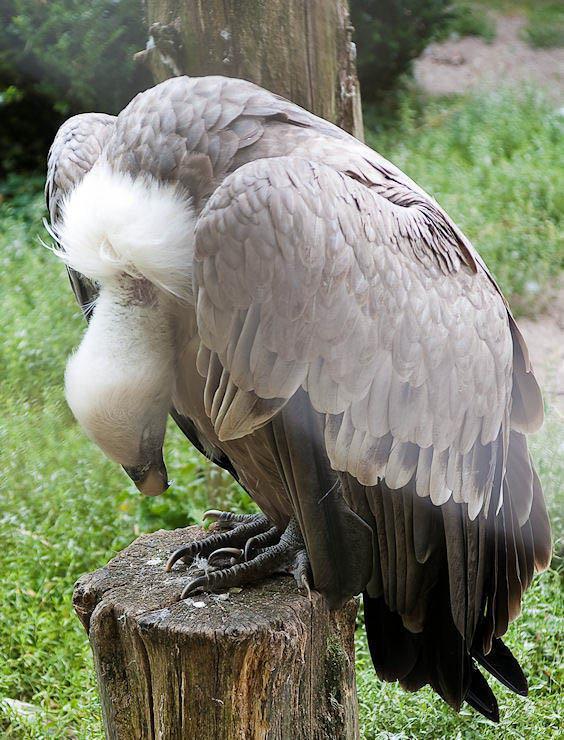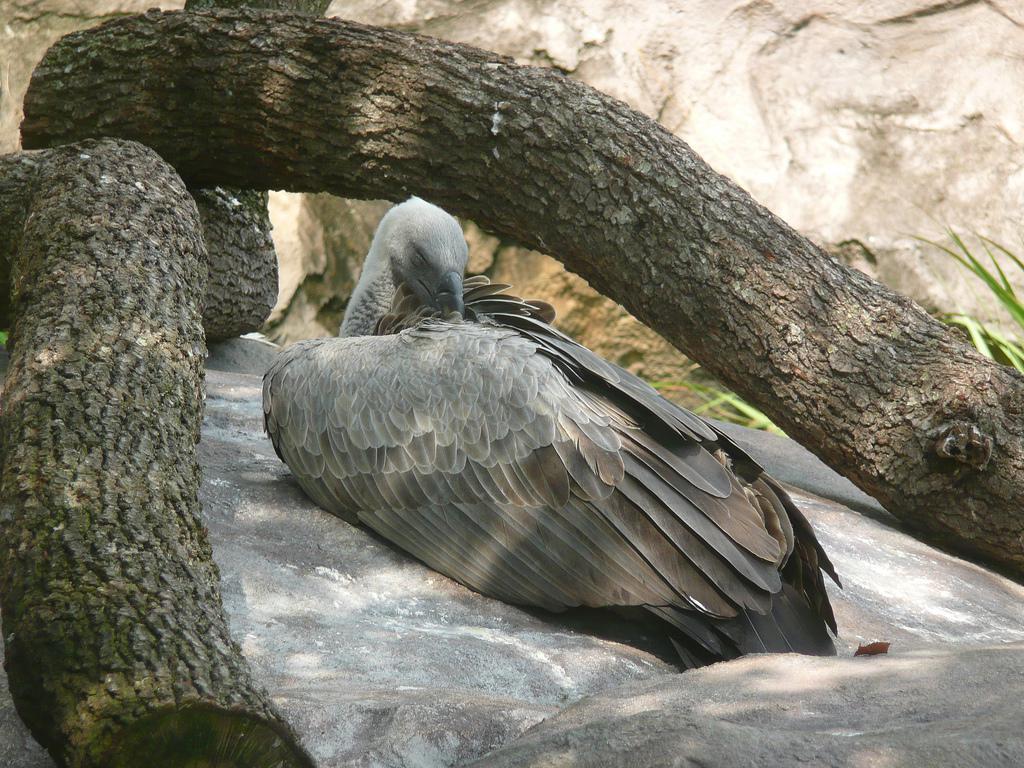The first image is the image on the left, the second image is the image on the right. Considering the images on both sides, is "An image shows one vulture with its white fuzzy-feathered head on the left of the picture." valid? Answer yes or no. Yes. The first image is the image on the left, the second image is the image on the right. Given the left and right images, does the statement "The bird in the image on the right is lying down." hold true? Answer yes or no. Yes. 